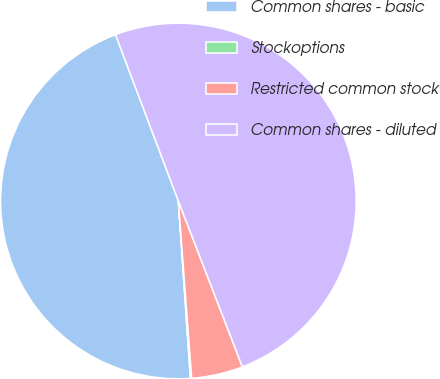Convert chart to OTSL. <chart><loc_0><loc_0><loc_500><loc_500><pie_chart><fcel>Common shares - basic<fcel>Stockoptions<fcel>Restricted common stock<fcel>Common shares - diluted<nl><fcel>45.33%<fcel>0.12%<fcel>4.67%<fcel>49.88%<nl></chart> 